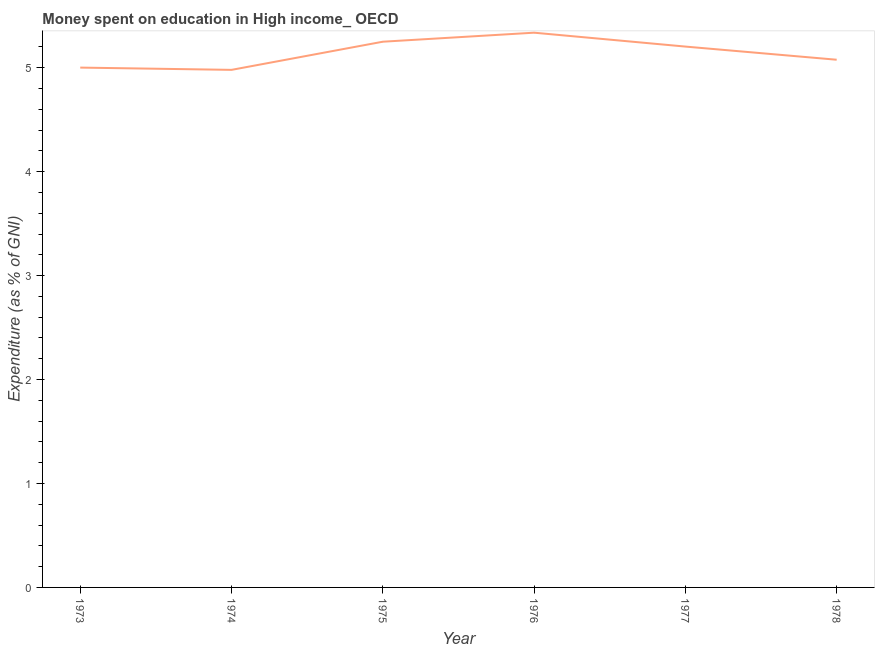What is the expenditure on education in 1978?
Give a very brief answer. 5.08. Across all years, what is the maximum expenditure on education?
Make the answer very short. 5.34. Across all years, what is the minimum expenditure on education?
Offer a terse response. 4.98. In which year was the expenditure on education maximum?
Your answer should be very brief. 1976. In which year was the expenditure on education minimum?
Provide a succinct answer. 1974. What is the sum of the expenditure on education?
Provide a short and direct response. 30.85. What is the difference between the expenditure on education in 1977 and 1978?
Your answer should be compact. 0.13. What is the average expenditure on education per year?
Offer a terse response. 5.14. What is the median expenditure on education?
Make the answer very short. 5.14. In how many years, is the expenditure on education greater than 0.2 %?
Provide a short and direct response. 6. What is the ratio of the expenditure on education in 1973 to that in 1978?
Provide a short and direct response. 0.99. Is the difference between the expenditure on education in 1975 and 1977 greater than the difference between any two years?
Keep it short and to the point. No. What is the difference between the highest and the second highest expenditure on education?
Give a very brief answer. 0.09. Is the sum of the expenditure on education in 1976 and 1978 greater than the maximum expenditure on education across all years?
Ensure brevity in your answer.  Yes. What is the difference between the highest and the lowest expenditure on education?
Ensure brevity in your answer.  0.36. Does the expenditure on education monotonically increase over the years?
Offer a terse response. No. How many lines are there?
Offer a very short reply. 1. How many years are there in the graph?
Offer a very short reply. 6. What is the difference between two consecutive major ticks on the Y-axis?
Your answer should be compact. 1. Are the values on the major ticks of Y-axis written in scientific E-notation?
Provide a succinct answer. No. What is the title of the graph?
Provide a succinct answer. Money spent on education in High income_ OECD. What is the label or title of the Y-axis?
Give a very brief answer. Expenditure (as % of GNI). What is the Expenditure (as % of GNI) of 1973?
Provide a succinct answer. 5. What is the Expenditure (as % of GNI) of 1974?
Your response must be concise. 4.98. What is the Expenditure (as % of GNI) in 1975?
Make the answer very short. 5.25. What is the Expenditure (as % of GNI) of 1976?
Your answer should be very brief. 5.34. What is the Expenditure (as % of GNI) of 1977?
Give a very brief answer. 5.2. What is the Expenditure (as % of GNI) of 1978?
Ensure brevity in your answer.  5.08. What is the difference between the Expenditure (as % of GNI) in 1973 and 1974?
Make the answer very short. 0.02. What is the difference between the Expenditure (as % of GNI) in 1973 and 1975?
Your response must be concise. -0.25. What is the difference between the Expenditure (as % of GNI) in 1973 and 1976?
Your response must be concise. -0.34. What is the difference between the Expenditure (as % of GNI) in 1973 and 1977?
Keep it short and to the point. -0.2. What is the difference between the Expenditure (as % of GNI) in 1973 and 1978?
Give a very brief answer. -0.08. What is the difference between the Expenditure (as % of GNI) in 1974 and 1975?
Provide a short and direct response. -0.27. What is the difference between the Expenditure (as % of GNI) in 1974 and 1976?
Offer a very short reply. -0.36. What is the difference between the Expenditure (as % of GNI) in 1974 and 1977?
Provide a short and direct response. -0.22. What is the difference between the Expenditure (as % of GNI) in 1974 and 1978?
Keep it short and to the point. -0.1. What is the difference between the Expenditure (as % of GNI) in 1975 and 1976?
Keep it short and to the point. -0.09. What is the difference between the Expenditure (as % of GNI) in 1975 and 1977?
Your answer should be compact. 0.05. What is the difference between the Expenditure (as % of GNI) in 1975 and 1978?
Your response must be concise. 0.17. What is the difference between the Expenditure (as % of GNI) in 1976 and 1977?
Make the answer very short. 0.13. What is the difference between the Expenditure (as % of GNI) in 1976 and 1978?
Make the answer very short. 0.26. What is the difference between the Expenditure (as % of GNI) in 1977 and 1978?
Provide a short and direct response. 0.13. What is the ratio of the Expenditure (as % of GNI) in 1973 to that in 1974?
Provide a short and direct response. 1. What is the ratio of the Expenditure (as % of GNI) in 1973 to that in 1975?
Your answer should be compact. 0.95. What is the ratio of the Expenditure (as % of GNI) in 1973 to that in 1976?
Make the answer very short. 0.94. What is the ratio of the Expenditure (as % of GNI) in 1974 to that in 1975?
Give a very brief answer. 0.95. What is the ratio of the Expenditure (as % of GNI) in 1974 to that in 1976?
Your response must be concise. 0.93. What is the ratio of the Expenditure (as % of GNI) in 1974 to that in 1977?
Give a very brief answer. 0.96. What is the ratio of the Expenditure (as % of GNI) in 1974 to that in 1978?
Your response must be concise. 0.98. What is the ratio of the Expenditure (as % of GNI) in 1975 to that in 1976?
Offer a terse response. 0.98. What is the ratio of the Expenditure (as % of GNI) in 1975 to that in 1977?
Make the answer very short. 1.01. What is the ratio of the Expenditure (as % of GNI) in 1975 to that in 1978?
Your answer should be very brief. 1.03. What is the ratio of the Expenditure (as % of GNI) in 1976 to that in 1978?
Your answer should be very brief. 1.05. 